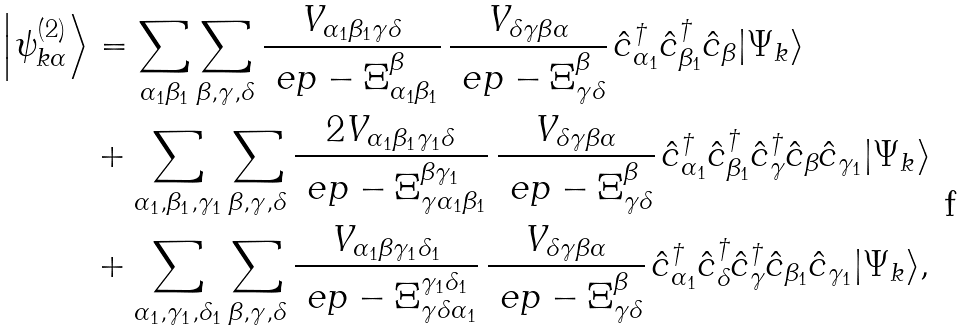<formula> <loc_0><loc_0><loc_500><loc_500>\left | \psi _ { k \alpha } ^ { ( 2 ) } \right \rangle & = \sum _ { \alpha _ { 1 } \beta _ { 1 } } \sum _ { \beta , \gamma , \delta } \frac { V _ { \alpha _ { 1 } \beta _ { 1 } \gamma \delta } } { \ e p - \Xi _ { \alpha _ { 1 } \beta _ { 1 } } ^ { \beta } } \, \frac { V _ { \delta \gamma \beta \alpha } } { \ e p - \Xi _ { \gamma \delta } ^ { \beta } } \, \hat { c } ^ { \dagger } _ { \alpha _ { 1 } } \hat { c } ^ { \dagger } _ { \beta _ { 1 } } \hat { c } _ { \beta } | \Psi _ { k } \rangle \\ & + \sum _ { \alpha _ { 1 } , \beta _ { 1 } , \gamma _ { 1 } } \sum _ { \beta , \gamma , \delta } \frac { 2 V _ { \alpha _ { 1 } \beta _ { 1 } \gamma _ { 1 } \delta } } { \ e p - \Xi _ { \gamma \alpha _ { 1 } \beta _ { 1 } } ^ { \beta \gamma _ { 1 } } } \, \frac { V _ { \delta \gamma \beta \alpha } } { \ e p - \Xi _ { \gamma \delta } ^ { \beta } } \, \hat { c } ^ { \dagger } _ { \alpha _ { 1 } } \hat { c } ^ { \dagger } _ { \beta _ { 1 } } \hat { c } ^ { \dagger } _ { \gamma } \hat { c } _ { \beta } \hat { c } _ { \gamma _ { 1 } } | \Psi _ { k } \rangle \\ & + \sum _ { \alpha _ { 1 } , \gamma _ { 1 } , \delta _ { 1 } } \sum _ { \beta , \gamma , \delta } \frac { V _ { \alpha _ { 1 } \beta \gamma _ { 1 } \delta _ { 1 } } } { \ e p - \Xi _ { \gamma \delta \alpha _ { 1 } } ^ { \gamma _ { 1 } \delta _ { 1 } } } \, \frac { V _ { \delta \gamma \beta \alpha } } { \ e p - \Xi _ { \gamma \delta } ^ { \beta } } \, \hat { c } ^ { \dagger } _ { \alpha _ { 1 } } \hat { c } ^ { \dagger } _ { \delta } \hat { c } ^ { \dagger } _ { \gamma } \hat { c } _ { \beta _ { 1 } } \hat { c } _ { \gamma _ { 1 } } | \Psi _ { k } \rangle ,</formula> 